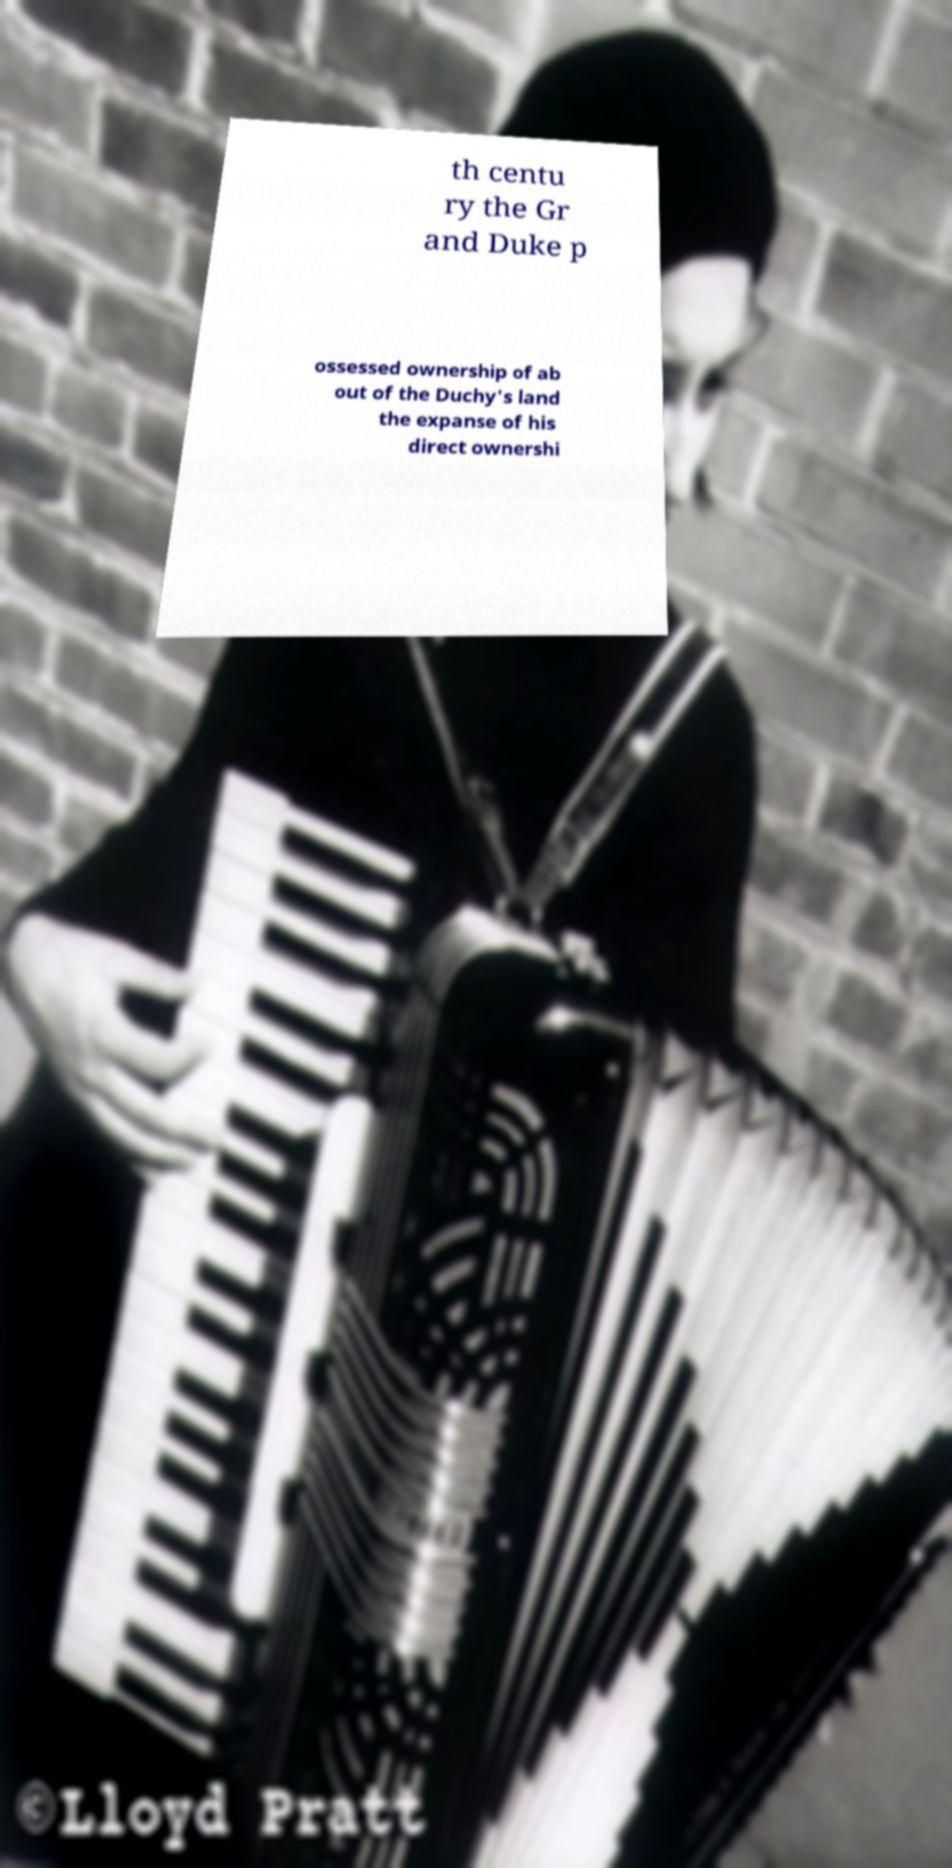Can you read and provide the text displayed in the image?This photo seems to have some interesting text. Can you extract and type it out for me? th centu ry the Gr and Duke p ossessed ownership of ab out of the Duchy's land the expanse of his direct ownershi 